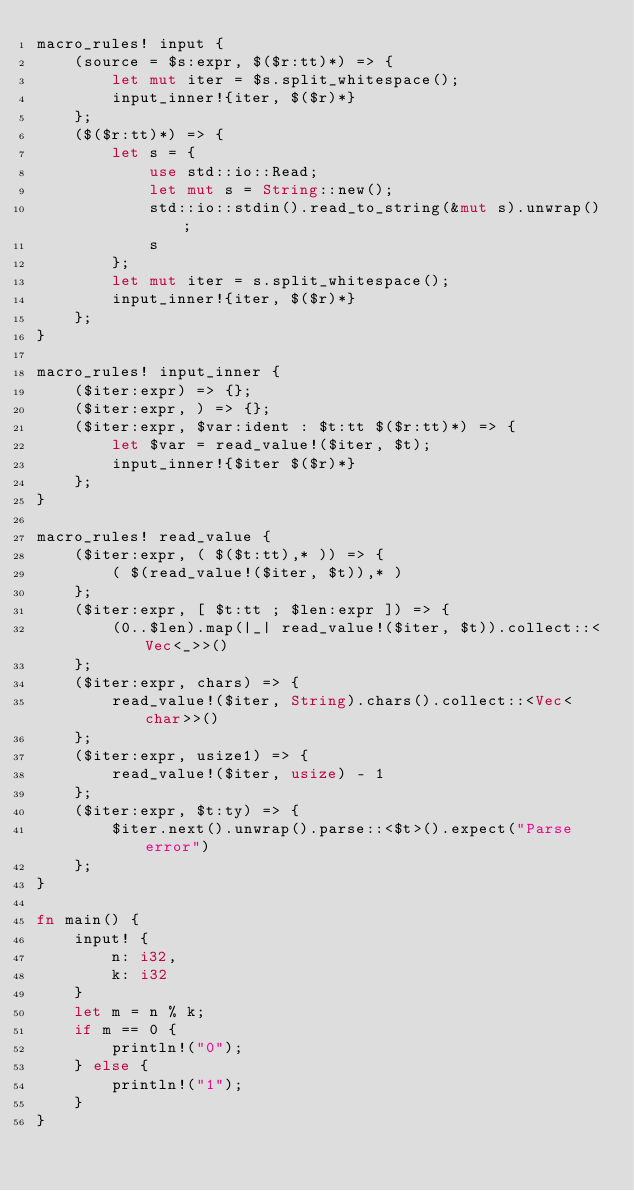Convert code to text. <code><loc_0><loc_0><loc_500><loc_500><_Rust_>macro_rules! input {
    (source = $s:expr, $($r:tt)*) => {
        let mut iter = $s.split_whitespace();
        input_inner!{iter, $($r)*}
    };
    ($($r:tt)*) => {
        let s = {
            use std::io::Read;
            let mut s = String::new();
            std::io::stdin().read_to_string(&mut s).unwrap();
            s
        };
        let mut iter = s.split_whitespace();
        input_inner!{iter, $($r)*}
    };
}

macro_rules! input_inner {
    ($iter:expr) => {};
    ($iter:expr, ) => {};
    ($iter:expr, $var:ident : $t:tt $($r:tt)*) => {
        let $var = read_value!($iter, $t);
        input_inner!{$iter $($r)*}
    };
}

macro_rules! read_value {
    ($iter:expr, ( $($t:tt),* )) => {
        ( $(read_value!($iter, $t)),* )
    };
    ($iter:expr, [ $t:tt ; $len:expr ]) => {
        (0..$len).map(|_| read_value!($iter, $t)).collect::<Vec<_>>()
    };
    ($iter:expr, chars) => {
        read_value!($iter, String).chars().collect::<Vec<char>>()
    };
    ($iter:expr, usize1) => {
        read_value!($iter, usize) - 1
    };
    ($iter:expr, $t:ty) => {
        $iter.next().unwrap().parse::<$t>().expect("Parse error")
    };
}

fn main() {
    input! {
        n: i32,
        k: i32
    }
    let m = n % k;
    if m == 0 {
        println!("0");
    } else {
        println!("1");
    }
}
</code> 